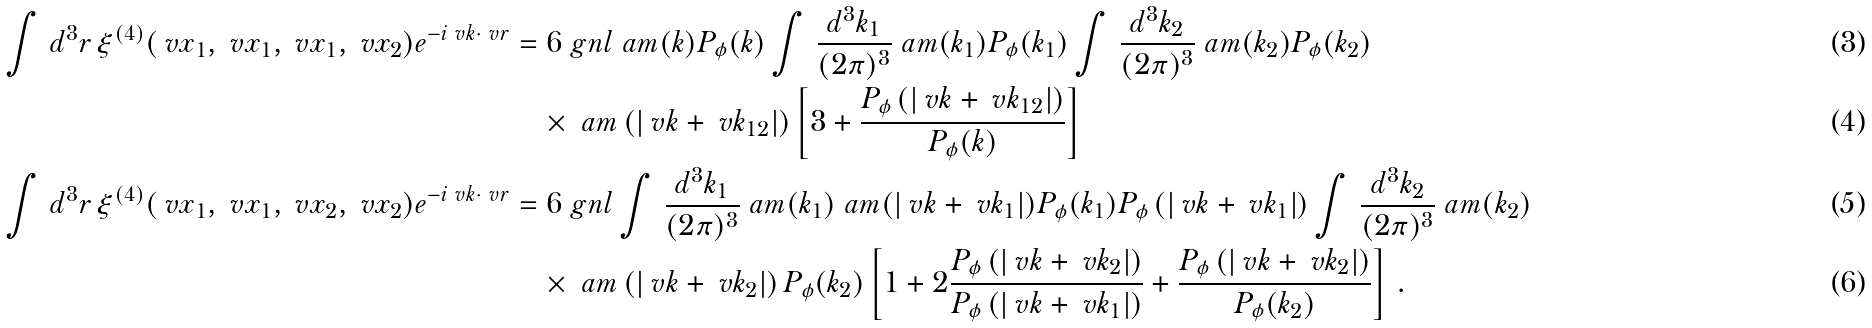Convert formula to latex. <formula><loc_0><loc_0><loc_500><loc_500>\int \, d ^ { 3 } r \, \xi ^ { ( 4 ) } ( \ v x _ { 1 } , \ v x _ { 1 } , \ v x _ { 1 } , \ v x _ { 2 } ) e ^ { - i \ v k \cdot \ v r } & = 6 \ g n l \ a m ( k ) P _ { \phi } ( k ) \int \, \frac { d ^ { 3 } k _ { 1 } } { ( 2 \pi ) ^ { 3 } } \ a m ( k _ { 1 } ) P _ { \phi } ( k _ { 1 } ) \int \, \frac { d ^ { 3 } k _ { 2 } } { ( 2 \pi ) ^ { 3 } } \ a m ( k _ { 2 } ) P _ { \phi } ( k _ { 2 } ) \\ & \quad \times \ a m \left ( | \ v k + \ v k _ { 1 2 } | \right ) \left [ 3 + \frac { P _ { \phi } \left ( | \ v k + \ v k _ { 1 2 } | \right ) } { P _ { \phi } ( k ) } \right ] \\ \int \, d ^ { 3 } r \, \xi ^ { ( 4 ) } ( \ v x _ { 1 } , \ v x _ { 1 } , \ v x _ { 2 } , \ v x _ { 2 } ) e ^ { - i \ v k \cdot \ v r } & = 6 \ g n l \int \, \frac { d ^ { 3 } k _ { 1 } } { ( 2 \pi ) ^ { 3 } } \ a m ( k _ { 1 } ) \ a m ( | \ v k + \ v k _ { 1 } | ) P _ { \phi } ( k _ { 1 } ) P _ { \phi } \left ( | \ v k + \ v k _ { 1 } | \right ) \int \, \frac { d ^ { 3 } k _ { 2 } } { ( 2 \pi ) ^ { 3 } } \ a m ( k _ { 2 } ) \\ & \quad \times \ a m \left ( | \ v k + \ v k _ { 2 } | \right ) P _ { \phi } ( k _ { 2 } ) \left [ 1 + 2 \frac { P _ { \phi } \left ( | \ v k + \ v k _ { 2 } | \right ) } { P _ { \phi } \left ( | \ v k + \ v k _ { 1 } | \right ) } + \frac { P _ { \phi } \left ( | \ v k + \ v k _ { 2 } | \right ) } { P _ { \phi } ( k _ { 2 } ) } \right ] \, .</formula> 